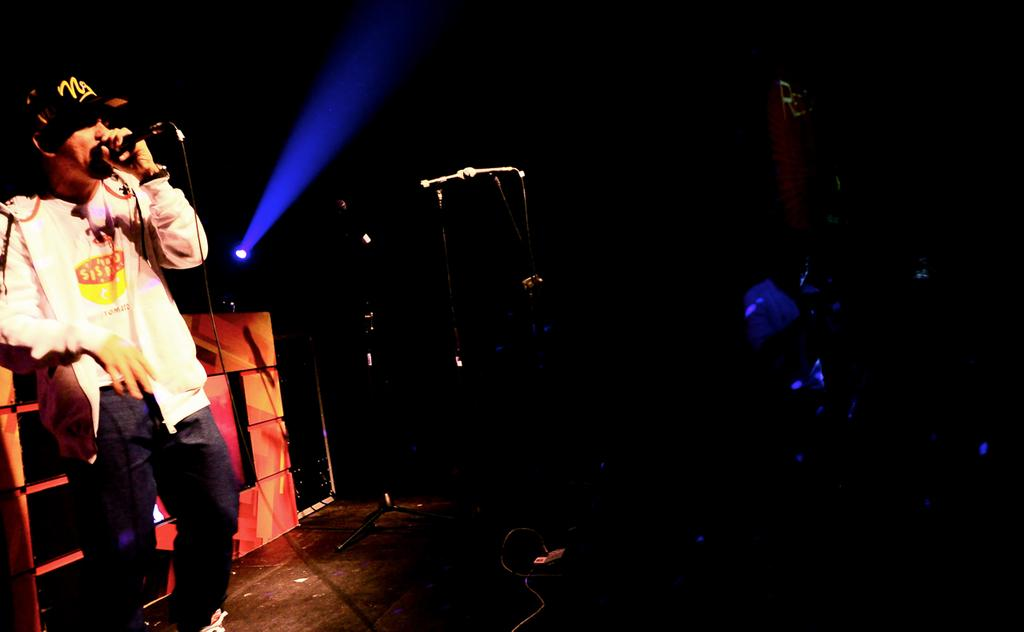What is the person on the left side of the image holding? The person on the left side of the image is holding a mic. What is in the center of the image? There is a mic stand in the center of the image. What can be seen in the background of the image? There is a light and a wall in the background of the image. What type of shoes is the person wearing at the event in the image? There is no information about shoes or an event in the image, as it only shows a person with a mic and a mic stand. 